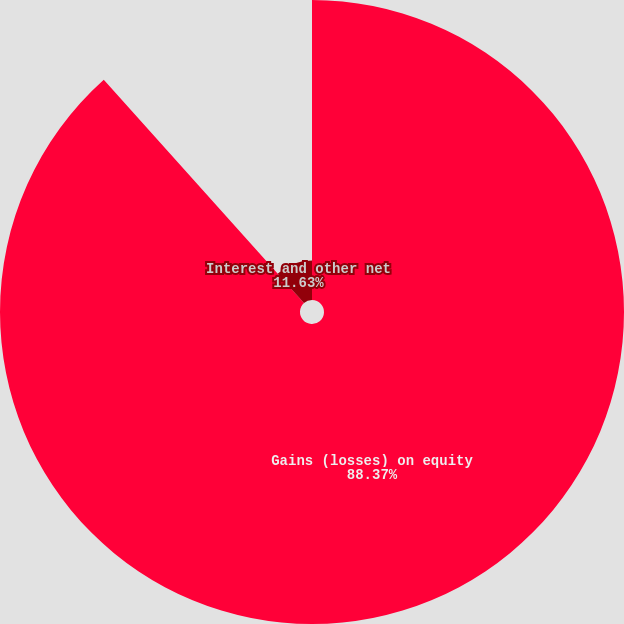<chart> <loc_0><loc_0><loc_500><loc_500><pie_chart><fcel>Gains (losses) on equity<fcel>Interest and other net<nl><fcel>88.37%<fcel>11.63%<nl></chart> 